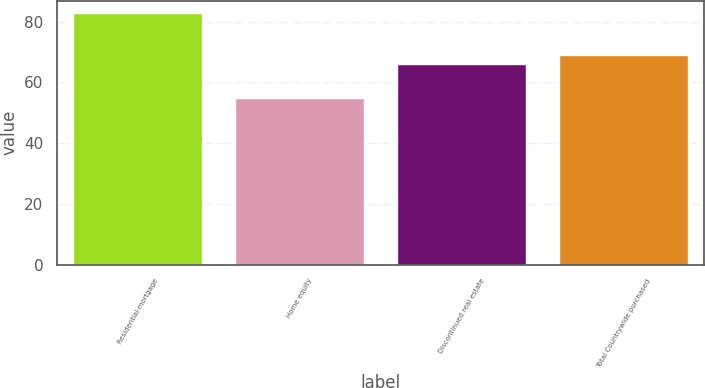Convert chart. <chart><loc_0><loc_0><loc_500><loc_500><bar_chart><fcel>Residential mortgage<fcel>Home equity<fcel>Discontinued real estate<fcel>Total Countrywide purchased<nl><fcel>82.82<fcel>54.72<fcel>66.08<fcel>68.89<nl></chart> 